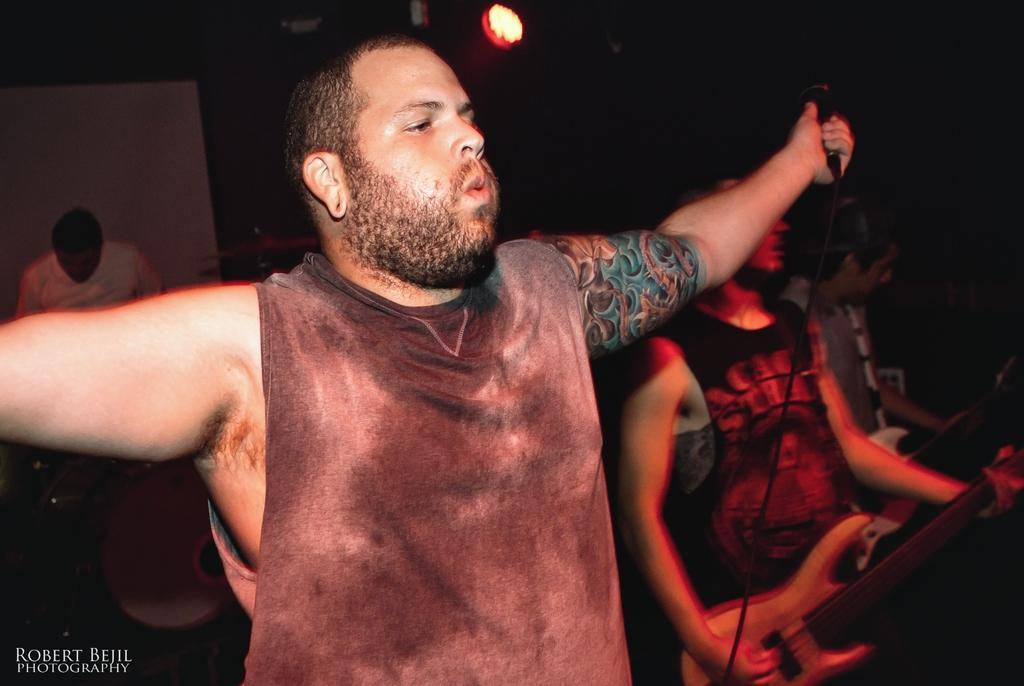Could you give a brief overview of what you see in this image? In this image I can see a man standing and holding a mike in his left hand. On the right side of the image I can see one more person is playing guitar. 